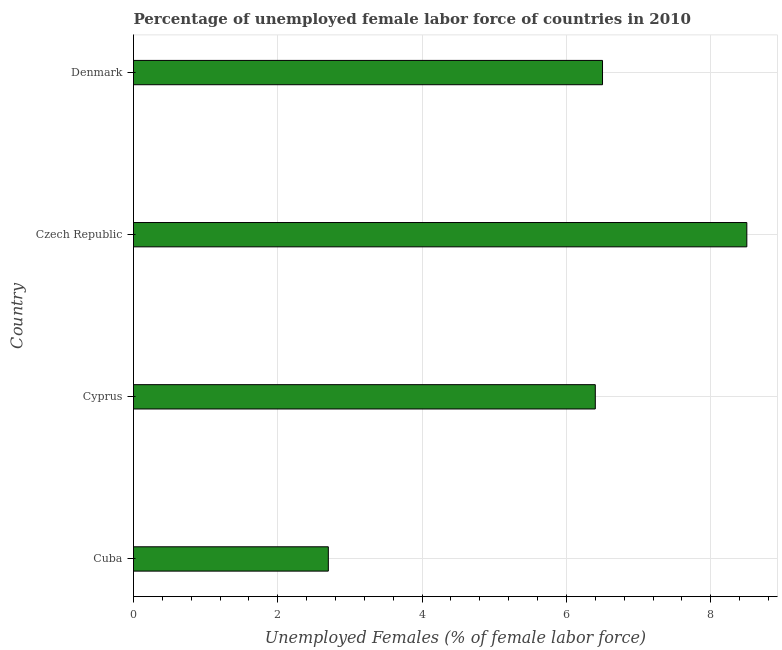Does the graph contain any zero values?
Keep it short and to the point. No. What is the title of the graph?
Your answer should be compact. Percentage of unemployed female labor force of countries in 2010. What is the label or title of the X-axis?
Your answer should be very brief. Unemployed Females (% of female labor force). What is the label or title of the Y-axis?
Your response must be concise. Country. Across all countries, what is the minimum total unemployed female labour force?
Offer a terse response. 2.7. In which country was the total unemployed female labour force maximum?
Keep it short and to the point. Czech Republic. In which country was the total unemployed female labour force minimum?
Your answer should be very brief. Cuba. What is the sum of the total unemployed female labour force?
Your response must be concise. 24.1. What is the difference between the total unemployed female labour force in Cyprus and Czech Republic?
Your answer should be very brief. -2.1. What is the average total unemployed female labour force per country?
Your response must be concise. 6.03. What is the median total unemployed female labour force?
Keep it short and to the point. 6.45. What is the ratio of the total unemployed female labour force in Cuba to that in Denmark?
Your answer should be compact. 0.41. Is the total unemployed female labour force in Cyprus less than that in Czech Republic?
Give a very brief answer. Yes. Is the sum of the total unemployed female labour force in Cyprus and Czech Republic greater than the maximum total unemployed female labour force across all countries?
Give a very brief answer. Yes. How many bars are there?
Offer a terse response. 4. How many countries are there in the graph?
Make the answer very short. 4. Are the values on the major ticks of X-axis written in scientific E-notation?
Make the answer very short. No. What is the Unemployed Females (% of female labor force) in Cuba?
Offer a very short reply. 2.7. What is the Unemployed Females (% of female labor force) of Cyprus?
Your response must be concise. 6.4. What is the Unemployed Females (% of female labor force) of Czech Republic?
Keep it short and to the point. 8.5. What is the Unemployed Females (% of female labor force) in Denmark?
Provide a short and direct response. 6.5. What is the difference between the Unemployed Females (% of female labor force) in Cuba and Cyprus?
Provide a short and direct response. -3.7. What is the difference between the Unemployed Females (% of female labor force) in Cuba and Czech Republic?
Keep it short and to the point. -5.8. What is the difference between the Unemployed Females (% of female labor force) in Cuba and Denmark?
Offer a terse response. -3.8. What is the difference between the Unemployed Females (% of female labor force) in Czech Republic and Denmark?
Keep it short and to the point. 2. What is the ratio of the Unemployed Females (% of female labor force) in Cuba to that in Cyprus?
Make the answer very short. 0.42. What is the ratio of the Unemployed Females (% of female labor force) in Cuba to that in Czech Republic?
Your response must be concise. 0.32. What is the ratio of the Unemployed Females (% of female labor force) in Cuba to that in Denmark?
Provide a succinct answer. 0.41. What is the ratio of the Unemployed Females (% of female labor force) in Cyprus to that in Czech Republic?
Ensure brevity in your answer.  0.75. What is the ratio of the Unemployed Females (% of female labor force) in Cyprus to that in Denmark?
Offer a terse response. 0.98. What is the ratio of the Unemployed Females (% of female labor force) in Czech Republic to that in Denmark?
Give a very brief answer. 1.31. 